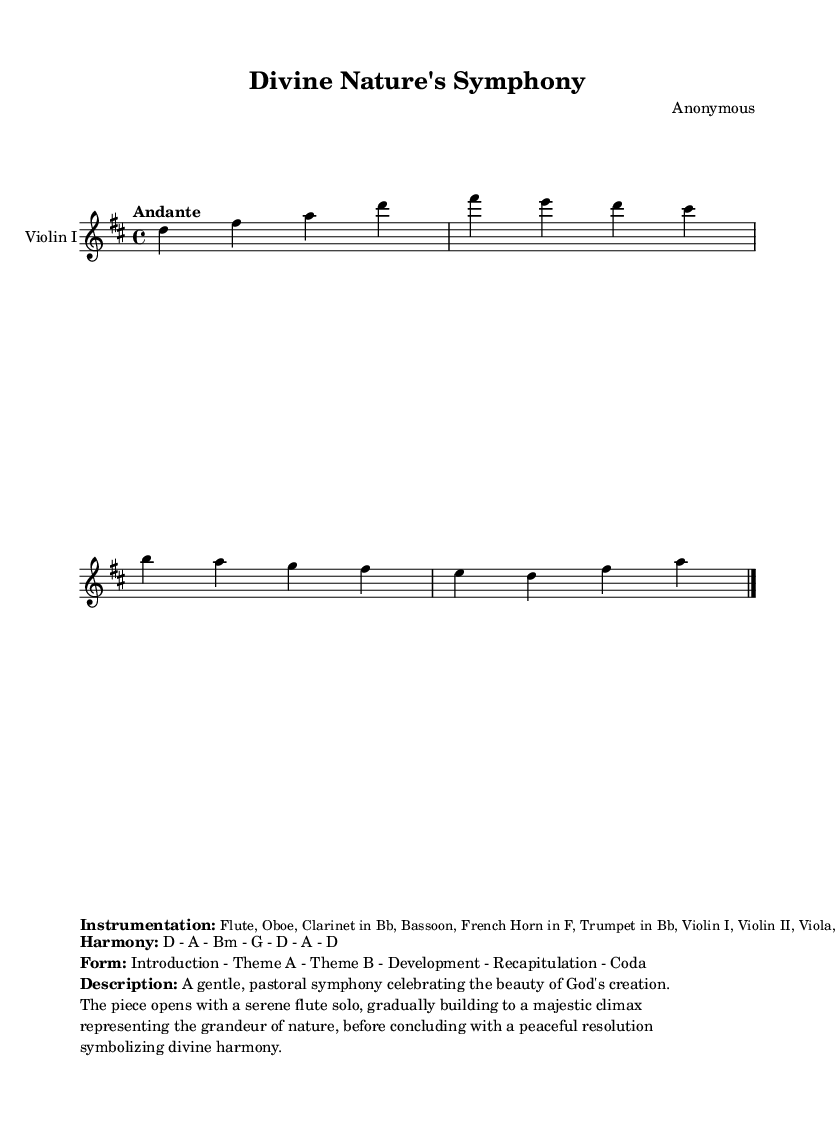What is the key signature of this music? The key signature is indicated at the beginning of the score, showing two sharps. This represents the D major key signature, as D major has F# and C#.
Answer: D major What is the time signature of this piece? The time signature is located after the key signature and consists of two numbers. It indicates that there are four beats in each measure and that the quarter note receives one beat. This is written as 4/4.
Answer: 4/4 What is the tempo marking for this symphony? The tempo marking is placed at the beginning of the score, typically above the staff. It indicates that the piece should be played in a slow, flowing manner. The marking given is "Andante."
Answer: Andante What are the instruments listed in the score? The instrumentation is specified in the markup section and is presented in a smaller font. It lists the instruments expected to perform the piece: Flute, Oboe, Clarinet in Bb, Bassoon, French Horn in F, Trumpet in Bb, Violin I, Violin II, Viola, Cello, Double Bass.
Answer: Flute, Oboe, Clarinet in Bb, Bassoon, French Horn in F, Trumpet in Bb, Violin I, Violin II, Viola, Cello, Double Bass What form does this symphony follow? The form is described in the markup section of the sheet music. It outlines the structure the piece adheres to, which includes an introduction, themes, development, recapitulation, and a coda.
Answer: Introduction - Theme A - Theme B - Development - Recapitulation - Coda What is the main theme or description of this symphony? The description is provided in the markup section, explaining the overall mood and focus of the piece. It indicates that it is a gentle, pastoral symphony celebrating God's creation, opening with a serene flute solo that builds to a majestic climax.
Answer: A gentle, pastoral symphony celebrating the beauty of God's creation 